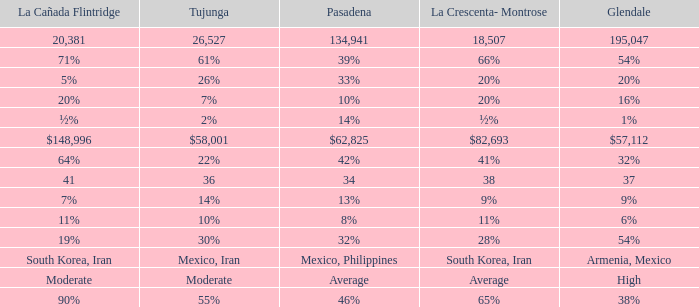When Pasadena is at 10%, what is La Crescenta-Montrose? 20%. 